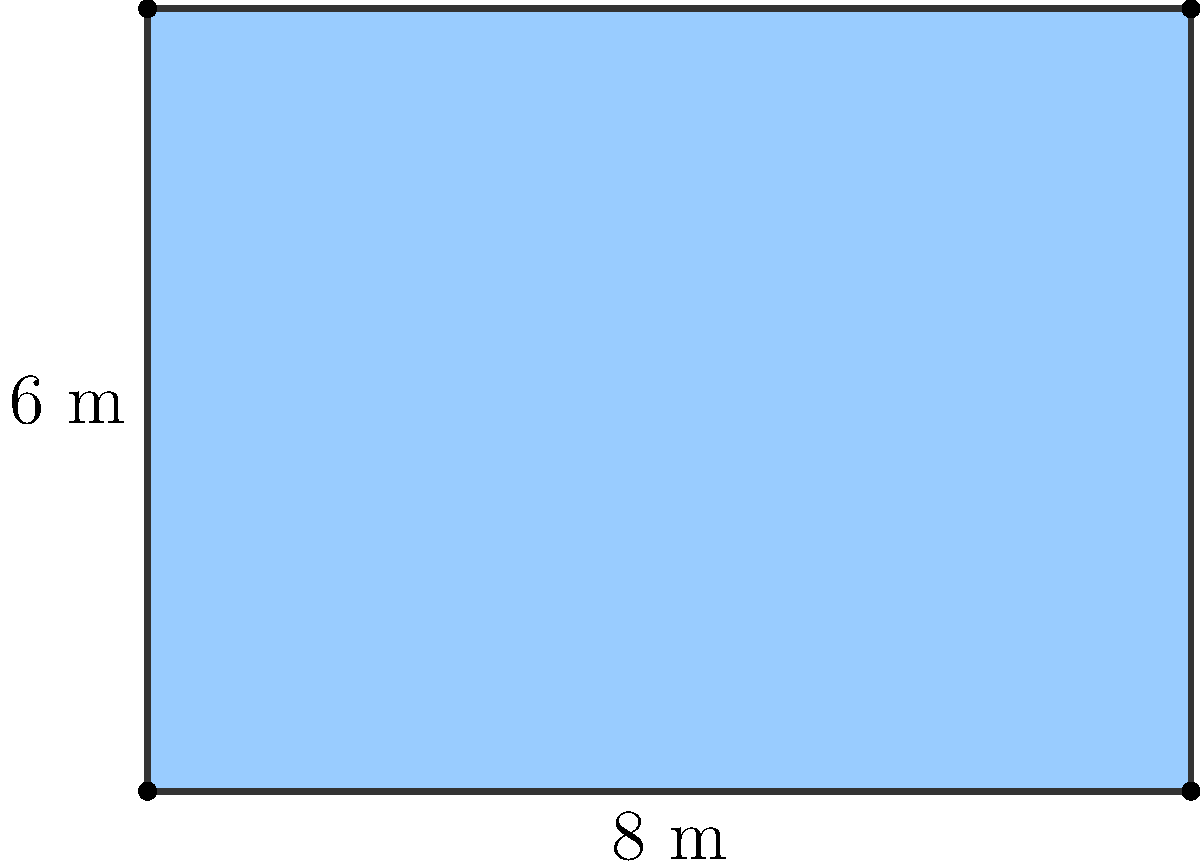As a retired architect, you're consulted on a project to design a rectangular building with a fixed perimeter of 28 meters. The current design has dimensions of 8 meters by 6 meters, as shown in the diagram. What should the dimensions of the building be to maximize the floor space, and what is the maximum area that can be achieved? Let's approach this step-by-step:

1) Let the width of the rectangle be $x$ and the length be $y$.

2) Given that the perimeter is fixed at 28 meters, we can write:
   $2x + 2y = 28$
   $x + y = 14$
   $y = 14 - x$

3) The area $A$ of the rectangle is given by:
   $A = xy = x(14-x) = 14x - x^2$

4) To find the maximum area, we need to find where the derivative of $A$ with respect to $x$ is zero:
   $\frac{dA}{dx} = 14 - 2x$

5) Setting this to zero:
   $14 - 2x = 0$
   $2x = 14$
   $x = 7$

6) Since $x + y = 14$, when $x = 7$, $y$ must also equal 7.

7) The second derivative $\frac{d^2A}{dx^2} = -2$ is negative, confirming this is a maximum.

8) The maximum area is therefore:
   $A = 7 \times 7 = 49$ square meters
Answer: Dimensions: 7 m × 7 m; Maximum area: 49 m² 